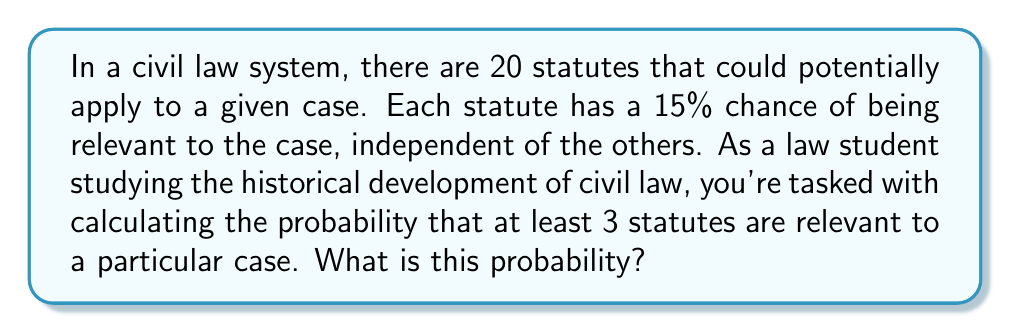Teach me how to tackle this problem. Let's approach this step-by-step:

1) This is a binomial probability problem. We have 20 independent trials (statutes), each with a 15% (0.15) probability of success (being relevant).

2) We want the probability of at least 3 successes, which is equivalent to 1 minus the probability of 0, 1, or 2 successes.

3) The probability mass function for a binomial distribution is:

   $$ P(X = k) = \binom{n}{k} p^k (1-p)^{n-k} $$

   Where n is the number of trials, k is the number of successes, and p is the probability of success.

4) In this case, n = 20, p = 0.15, and we need to calculate:

   $$ 1 - [P(X = 0) + P(X = 1) + P(X = 2)] $$

5) Let's calculate each term:

   $P(X = 0) = \binom{20}{0} 0.15^0 (0.85)^{20} = 0.0388$

   $P(X = 1) = \binom{20}{1} 0.15^1 (0.85)^{19} = 0.1368$

   $P(X = 2) = \binom{20}{2} 0.15^2 (0.85)^{18} = 0.2293$

6) Now, we can sum these probabilities and subtract from 1:

   $1 - (0.0388 + 0.1368 + 0.2293) = 1 - 0.4049 = 0.5951$

7) Therefore, the probability of at least 3 statutes being relevant is approximately 0.5951 or 59.51%.
Answer: 0.5951 